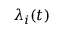<formula> <loc_0><loc_0><loc_500><loc_500>{ \lambda } _ { i } ( t )</formula> 